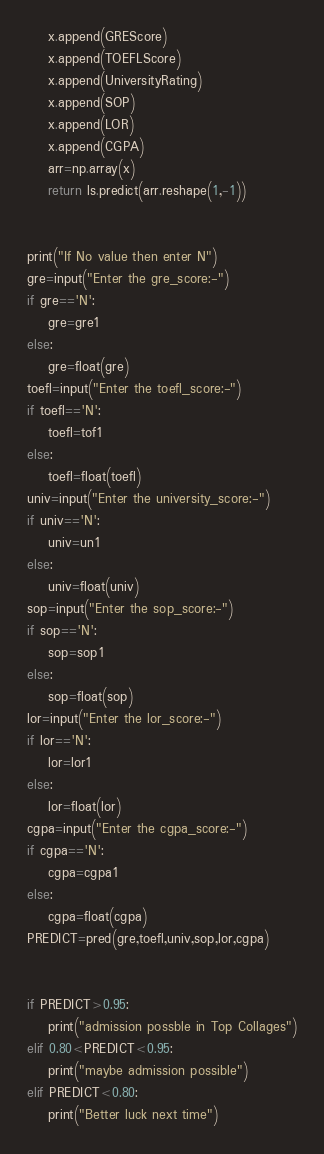Convert code to text. <code><loc_0><loc_0><loc_500><loc_500><_Python_>    x.append(GREScore)
    x.append(TOEFLScore)
    x.append(UniversityRating)
    x.append(SOP)
    x.append(LOR)
    x.append(CGPA)
    arr=np.array(x)
    return ls.predict(arr.reshape(1,-1))


print("If No value then enter N")
gre=input("Enter the gre_score:-")
if gre=='N':
    gre=gre1
else:
    gre=float(gre)
toefl=input("Enter the toefl_score:-")
if toefl=='N':
    toefl=tof1
else:
    toefl=float(toefl)
univ=input("Enter the university_score:-")
if univ=='N':
    univ=un1
else:
    univ=float(univ)
sop=input("Enter the sop_score:-")
if sop=='N':
    sop=sop1
else:
    sop=float(sop)
lor=input("Enter the lor_score:-")
if lor=='N':
    lor=lor1
else:
    lor=float(lor)
cgpa=input("Enter the cgpa_score:-")
if cgpa=='N':
    cgpa=cgpa1
else:
    cgpa=float(cgpa)
PREDICT=pred(gre,toefl,univ,sop,lor,cgpa)


if PREDICT>0.95:
    print("admission possble in Top Collages")
elif 0.80<PREDICT<0.95:
    print("maybe admission possible")
elif PREDICT<0.80:
    print("Better luck next time")


</code> 